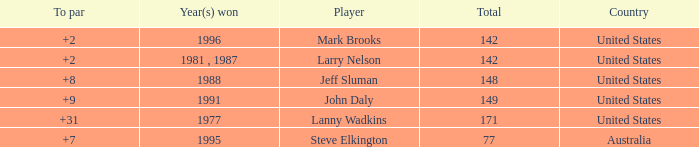Would you mind parsing the complete table? {'header': ['To par', 'Year(s) won', 'Player', 'Total', 'Country'], 'rows': [['+2', '1996', 'Mark Brooks', '142', 'United States'], ['+2', '1981 , 1987', 'Larry Nelson', '142', 'United States'], ['+8', '1988', 'Jeff Sluman', '148', 'United States'], ['+9', '1991', 'John Daly', '149', 'United States'], ['+31', '1977', 'Lanny Wadkins', '171', 'United States'], ['+7', '1995', 'Steve Elkington', '77', 'Australia']]} Name the Total of jeff sluman? 148.0. 